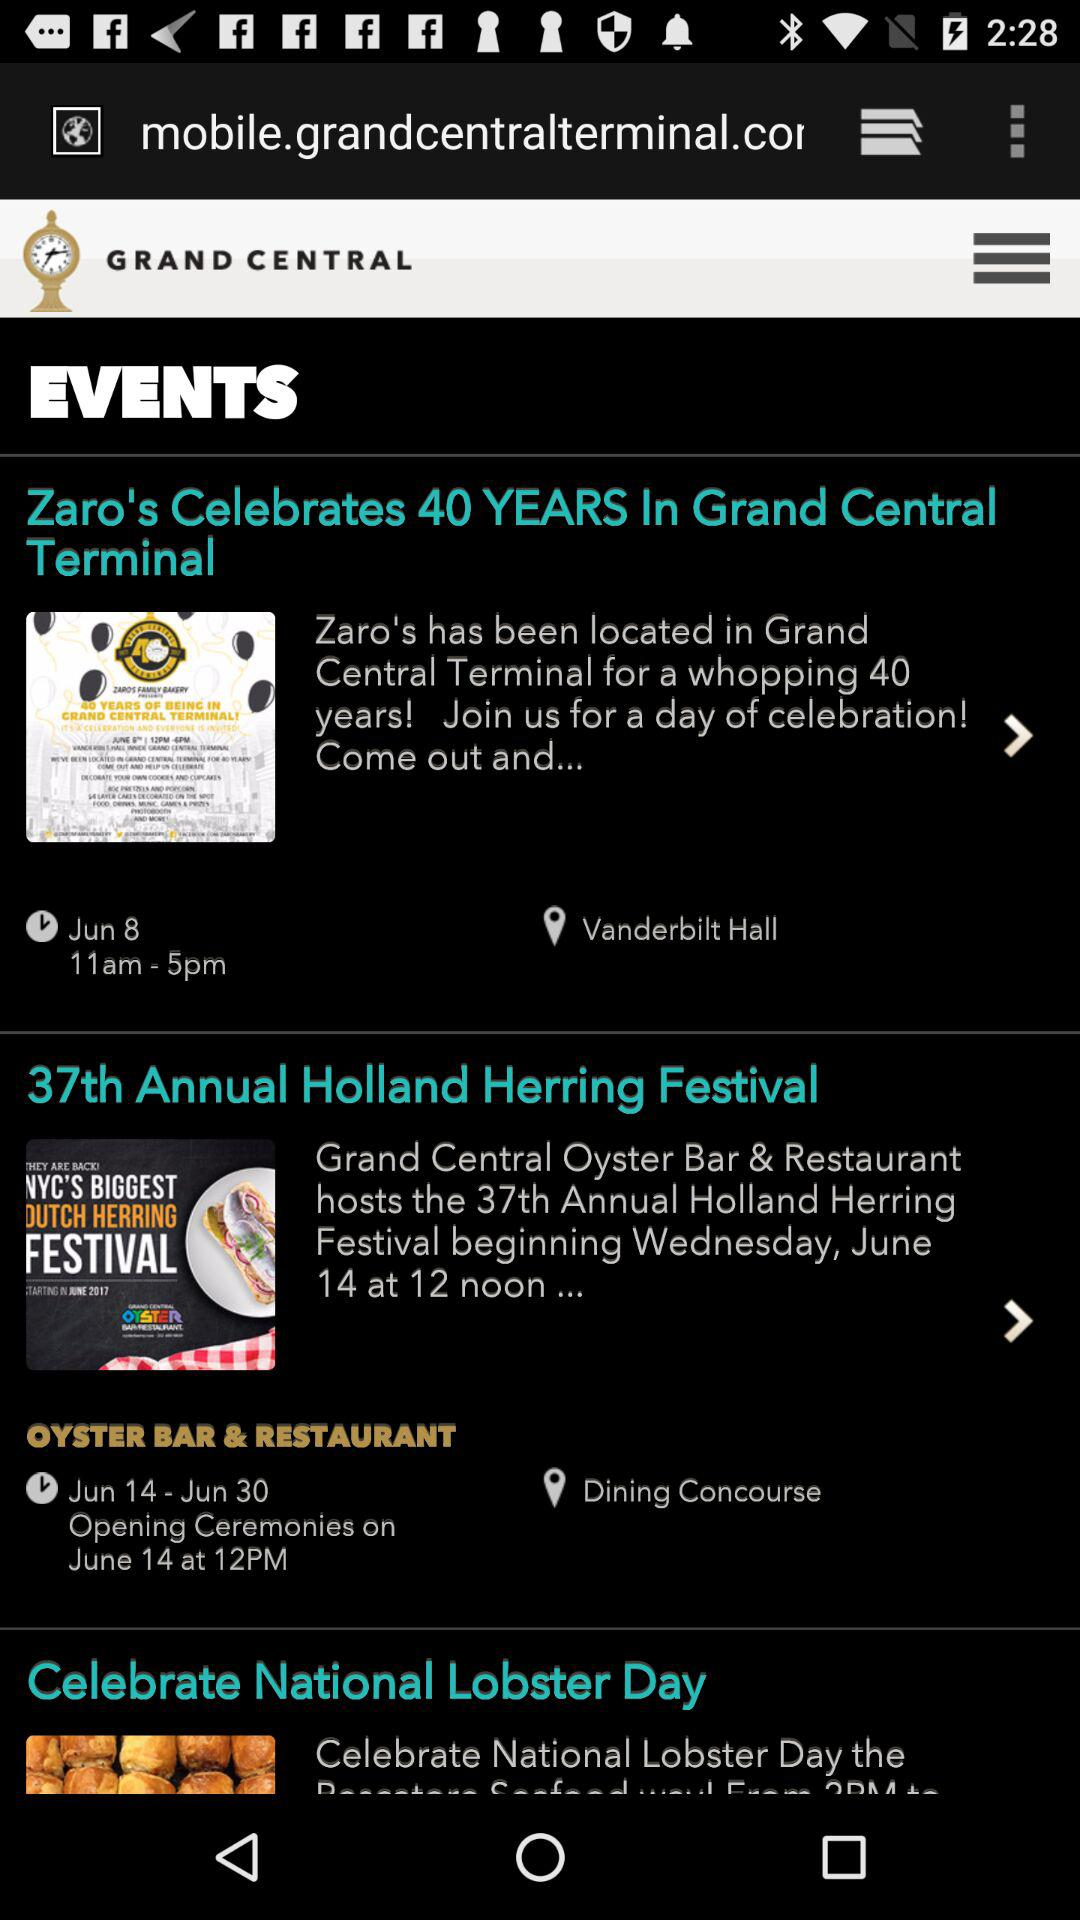What is the venue of the " Zaro's Celebrates 40 YEARS" event? The venue is Vanderbilt Hall. 